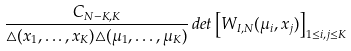<formula> <loc_0><loc_0><loc_500><loc_500>\frac { C _ { N - K , K } } { \triangle ( x _ { 1 } , \dots , x _ { K } ) \triangle ( \mu _ { 1 } , \dots , \mu _ { K } ) } \, d e t \left [ W _ { I , N } ( \mu _ { i } , x _ { j } ) \right ] _ { 1 \leq i , j \leq K }</formula> 